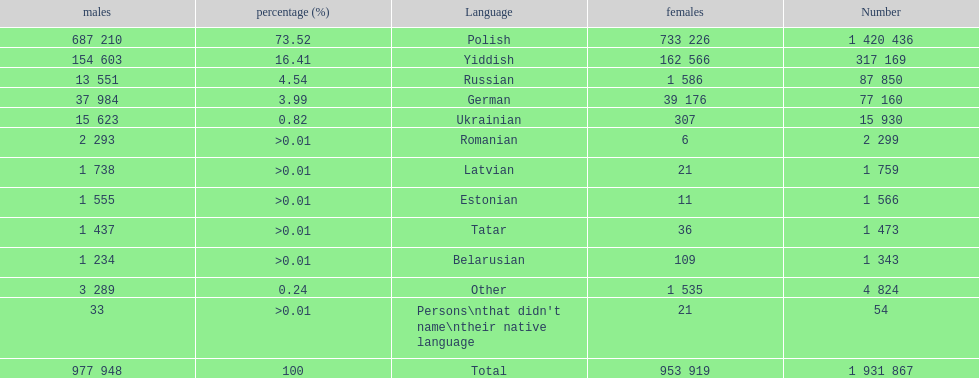Is german above or below russia in the number of people who speak that language? Below. 